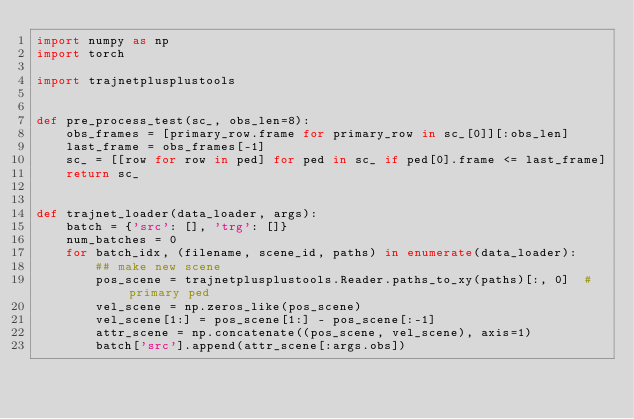<code> <loc_0><loc_0><loc_500><loc_500><_Python_>import numpy as np
import torch

import trajnetplusplustools


def pre_process_test(sc_, obs_len=8):
    obs_frames = [primary_row.frame for primary_row in sc_[0]][:obs_len]
    last_frame = obs_frames[-1]
    sc_ = [[row for row in ped] for ped in sc_ if ped[0].frame <= last_frame]
    return sc_


def trajnet_loader(data_loader, args):
    batch = {'src': [], 'trg': []}
    num_batches = 0
    for batch_idx, (filename, scene_id, paths) in enumerate(data_loader):
        ## make new scene
        pos_scene = trajnetplusplustools.Reader.paths_to_xy(paths)[:, 0]  # primary ped
        vel_scene = np.zeros_like(pos_scene)
        vel_scene[1:] = pos_scene[1:] - pos_scene[:-1]
        attr_scene = np.concatenate((pos_scene, vel_scene), axis=1)
        batch['src'].append(attr_scene[:args.obs])</code> 